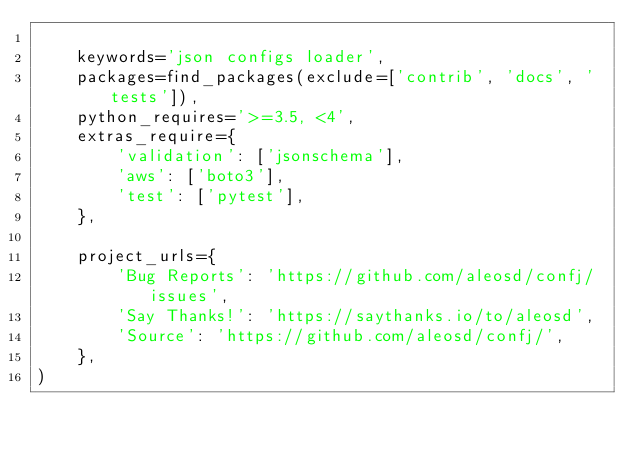<code> <loc_0><loc_0><loc_500><loc_500><_Python_>
    keywords='json configs loader',
    packages=find_packages(exclude=['contrib', 'docs', 'tests']),
    python_requires='>=3.5, <4',
    extras_require={
        'validation': ['jsonschema'],
        'aws': ['boto3'],
        'test': ['pytest'],
    },

    project_urls={
        'Bug Reports': 'https://github.com/aleosd/confj/issues',
        'Say Thanks!': 'https://saythanks.io/to/aleosd',
        'Source': 'https://github.com/aleosd/confj/',
    },
)
</code> 